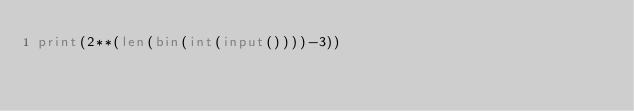Convert code to text. <code><loc_0><loc_0><loc_500><loc_500><_Python_>print(2**(len(bin(int(input())))-3))</code> 